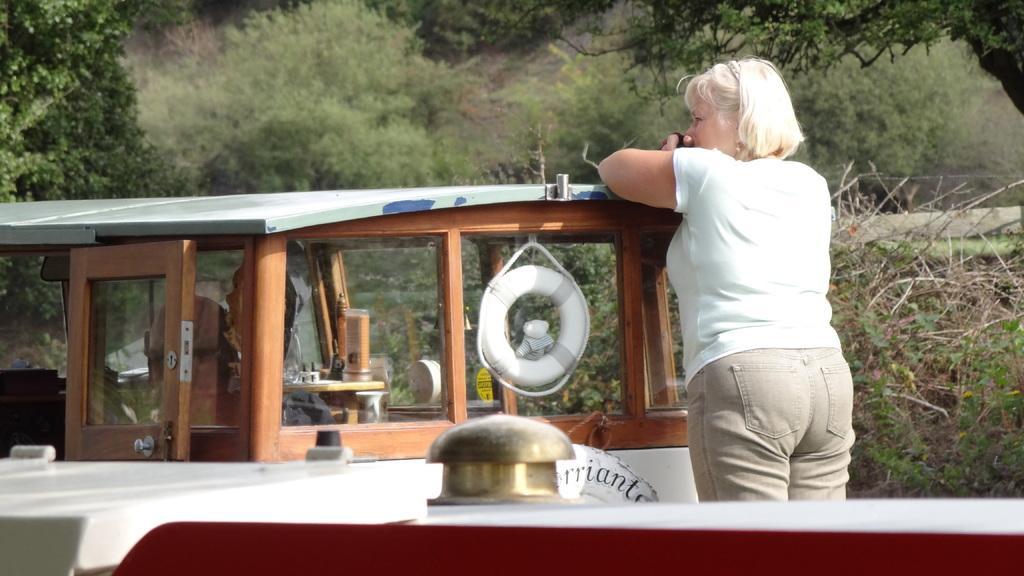Can you describe this image briefly? In the image we can see there is a woman standing on the ship and there is a tube. There is a wooden door and behind there are trees. 